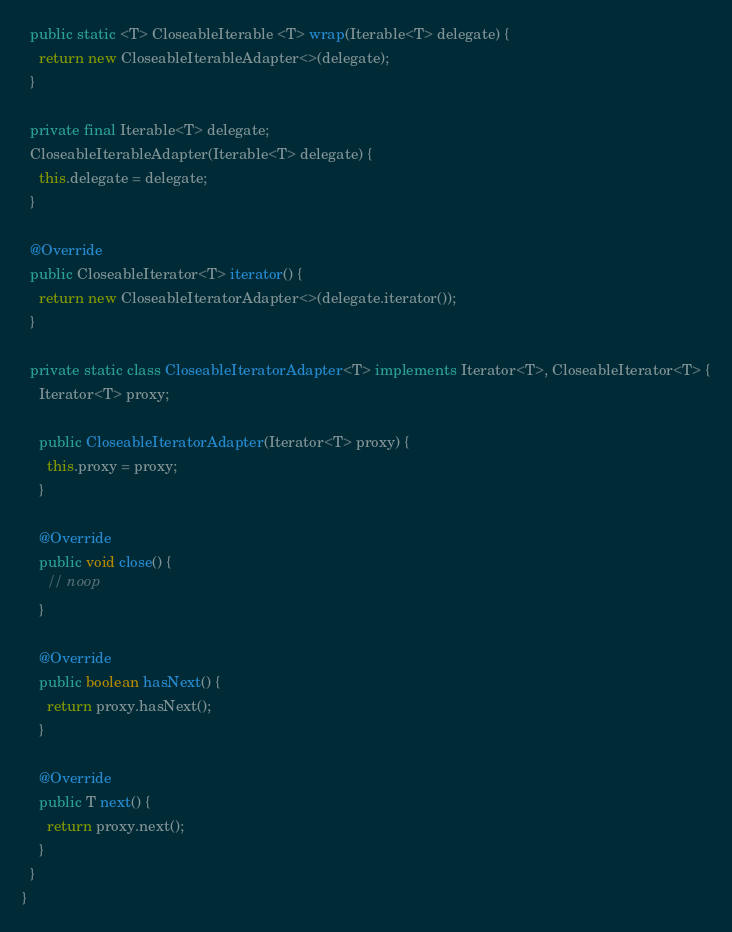Convert code to text. <code><loc_0><loc_0><loc_500><loc_500><_Java_>  public static <T> CloseableIterable <T> wrap(Iterable<T> delegate) {
    return new CloseableIterableAdapter<>(delegate);
  }

  private final Iterable<T> delegate;
  CloseableIterableAdapter(Iterable<T> delegate) {
    this.delegate = delegate;
  }

  @Override
  public CloseableIterator<T> iterator() {
    return new CloseableIteratorAdapter<>(delegate.iterator());
  }

  private static class CloseableIteratorAdapter<T> implements Iterator<T>, CloseableIterator<T> {
    Iterator<T> proxy;

    public CloseableIteratorAdapter(Iterator<T> proxy) {
      this.proxy = proxy;
    }

    @Override
    public void close() {
      // noop
    }

    @Override
    public boolean hasNext() {
      return proxy.hasNext();
    }

    @Override
    public T next() {
      return proxy.next();
    }
  }
}
</code> 